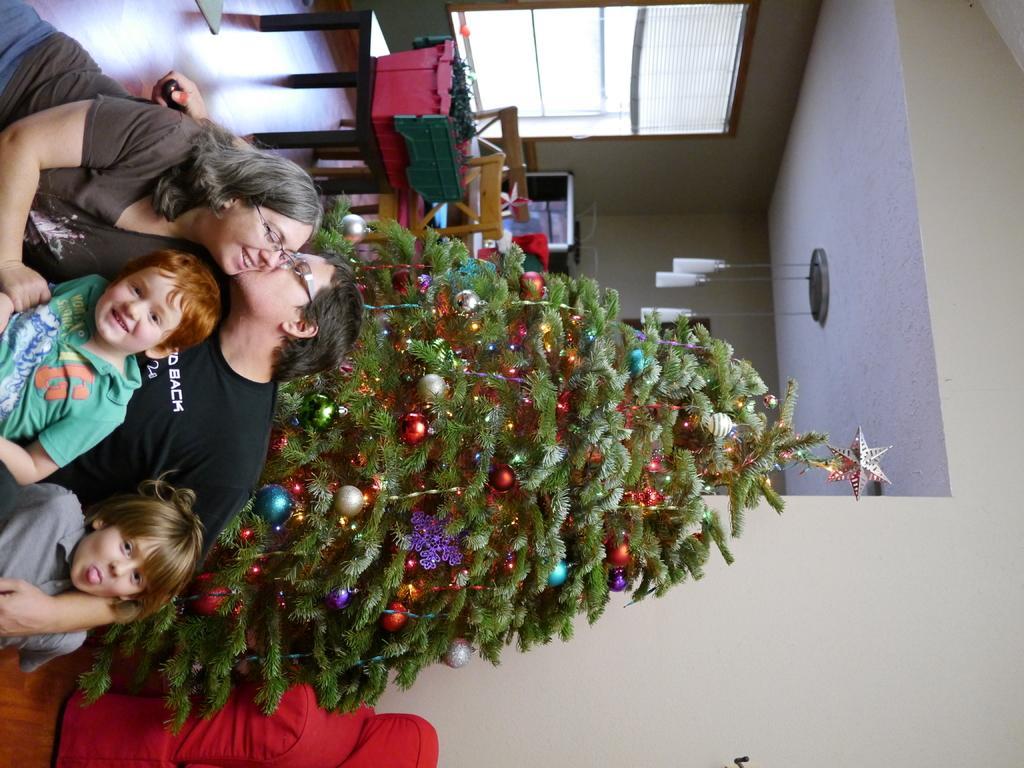How would you summarize this image in a sentence or two? In this image few persons are sitting before a Christmas tree which is decorated with few lights and few decorative items. Beside it there is a table having a pot having plants in it. Behind it there are few chairs. Few lights are hanged from the roof. Top of image there is window to the wall. Left bottom there is a chair. 